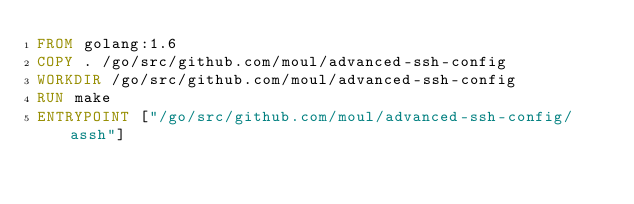<code> <loc_0><loc_0><loc_500><loc_500><_Dockerfile_>FROM golang:1.6
COPY . /go/src/github.com/moul/advanced-ssh-config
WORKDIR /go/src/github.com/moul/advanced-ssh-config
RUN make
ENTRYPOINT ["/go/src/github.com/moul/advanced-ssh-config/assh"]
</code> 